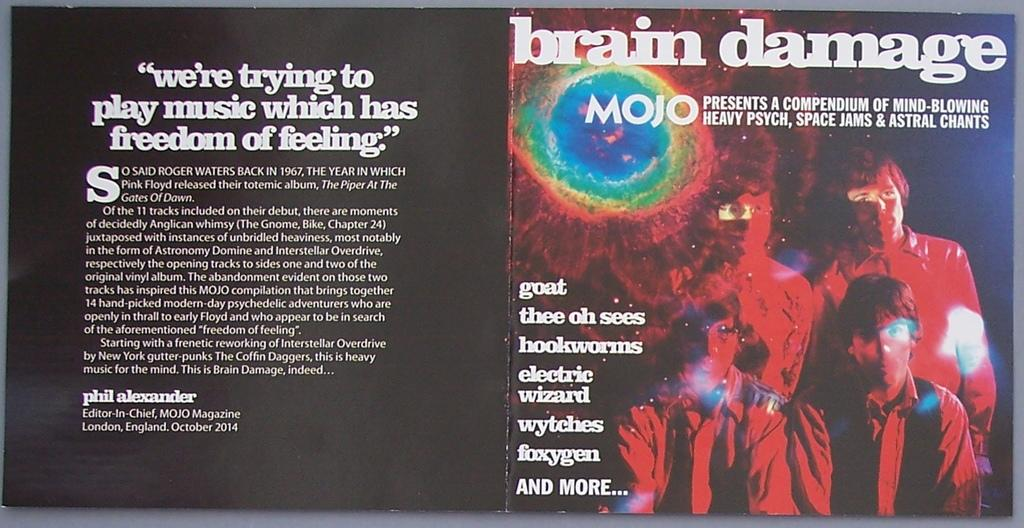<image>
Write a terse but informative summary of the picture. A music disc is open and titled brain damage. 